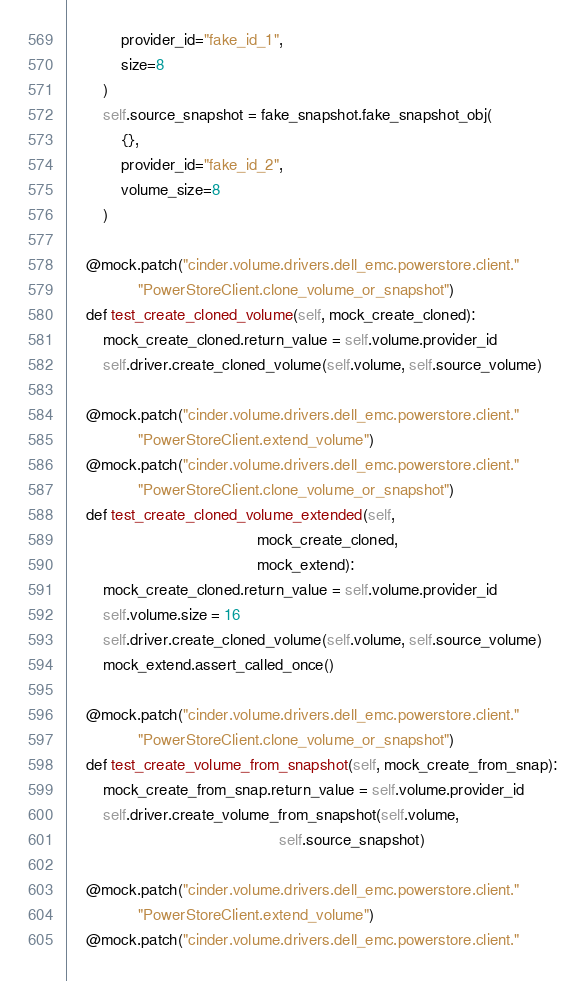Convert code to text. <code><loc_0><loc_0><loc_500><loc_500><_Python_>            provider_id="fake_id_1",
            size=8
        )
        self.source_snapshot = fake_snapshot.fake_snapshot_obj(
            {},
            provider_id="fake_id_2",
            volume_size=8
        )

    @mock.patch("cinder.volume.drivers.dell_emc.powerstore.client."
                "PowerStoreClient.clone_volume_or_snapshot")
    def test_create_cloned_volume(self, mock_create_cloned):
        mock_create_cloned.return_value = self.volume.provider_id
        self.driver.create_cloned_volume(self.volume, self.source_volume)

    @mock.patch("cinder.volume.drivers.dell_emc.powerstore.client."
                "PowerStoreClient.extend_volume")
    @mock.patch("cinder.volume.drivers.dell_emc.powerstore.client."
                "PowerStoreClient.clone_volume_or_snapshot")
    def test_create_cloned_volume_extended(self,
                                           mock_create_cloned,
                                           mock_extend):
        mock_create_cloned.return_value = self.volume.provider_id
        self.volume.size = 16
        self.driver.create_cloned_volume(self.volume, self.source_volume)
        mock_extend.assert_called_once()

    @mock.patch("cinder.volume.drivers.dell_emc.powerstore.client."
                "PowerStoreClient.clone_volume_or_snapshot")
    def test_create_volume_from_snapshot(self, mock_create_from_snap):
        mock_create_from_snap.return_value = self.volume.provider_id
        self.driver.create_volume_from_snapshot(self.volume,
                                                self.source_snapshot)

    @mock.patch("cinder.volume.drivers.dell_emc.powerstore.client."
                "PowerStoreClient.extend_volume")
    @mock.patch("cinder.volume.drivers.dell_emc.powerstore.client."</code> 